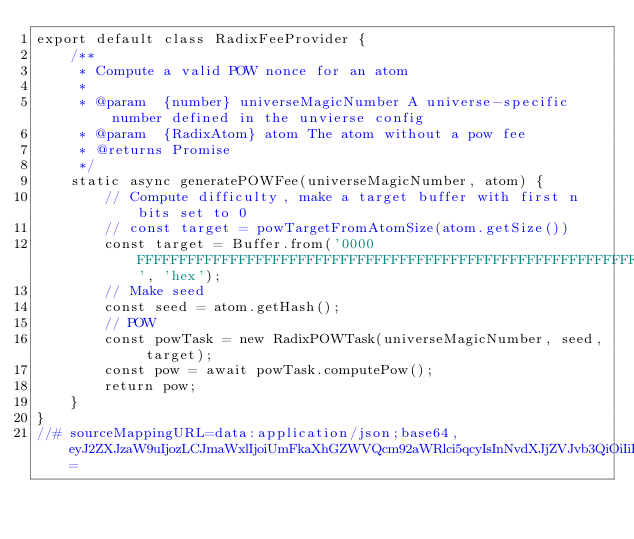<code> <loc_0><loc_0><loc_500><loc_500><_JavaScript_>export default class RadixFeeProvider {
    /**
     * Compute a valid POW nonce for an atom
     *
     * @param  {number} universeMagicNumber A universe-specific number defined in the unvierse config
     * @param  {RadixAtom} atom The atom without a pow fee
     * @returns Promise
     */
    static async generatePOWFee(universeMagicNumber, atom) {
        // Compute difficulty, make a target buffer with first n bits set to 0
        // const target = powTargetFromAtomSize(atom.getSize())
        const target = Buffer.from('0000FFFFFFFFFFFFFFFFFFFFFFFFFFFFFFFFFFFFFFFFFFFFFFFFFFFFFFFFFFFF', 'hex');
        // Make seed
        const seed = atom.getHash();
        // POW
        const powTask = new RadixPOWTask(universeMagicNumber, seed, target);
        const pow = await powTask.computePow();
        return pow;
    }
}
//# sourceMappingURL=data:application/json;base64,eyJ2ZXJzaW9uIjozLCJmaWxlIjoiUmFkaXhGZWVQcm92aWRlci5qcyIsInNvdXJjZVJvb3QiOiIiLCJzb3VyY2VzIjpbIi4uLy4uLy4uLy4uL3NyYy9tb2R1bGVzL2ZlZXMvUmFkaXhGZWVQcm92aWRlci50cyJdLCJuYW1lcyI6W10sIm1hcHBpbmdzIjoiQUFHQSxPQUFPLFlBQVksTUFBTSxxQkFBcUIsQ0FBQTtBQUs5QyxNQUFNLENBQUMsT0FBTyxPQUFPLGdCQUFnQjtJQUNqQzs7Ozs7O09BTUc7SUFFSSxNQUFNLENBQUMsS0FBSyxDQUFDLGNBQWMsQ0FDOUIsbUJBQTJCLEVBQzNCLElBQWU7UUFHZixzRUFBc0U7UUFDdEUsdURBQXVEO1FBQ3ZELE1BQU0sTUFBTSxHQUFHLE1BQU0sQ0FBQyxJQUFJLENBQUMsa0VBQWtFLEVBQUUsS0FBSyxDQUFDLENBQUE7UUFFckcsWUFBWTtRQUNaLE1BQU0sSUFBSSxHQUFHLElBQUksQ0FBQyxPQUFPLEVBQUUsQ0FBQTtRQUUzQixNQUFNO1FBQ04sTUFBTSxPQUFPLEdBQUcsSUFBSSxZQUFZLENBQUMsbUJBQW1CLEVBQUUsSUFBSSxFQUFFLE1BQU0sQ0FBQyxDQUFBO1FBQ25FLE1BQU0sR0FBRyxHQUFHLE1BQU0sT0FBTyxDQUFDLFVBQVUsRUFBRSxDQUFBO1FBRXRDLE9BQU8sR0FBRyxDQUFBO0lBQ2QsQ0FBQztDQUNKIn0=</code> 